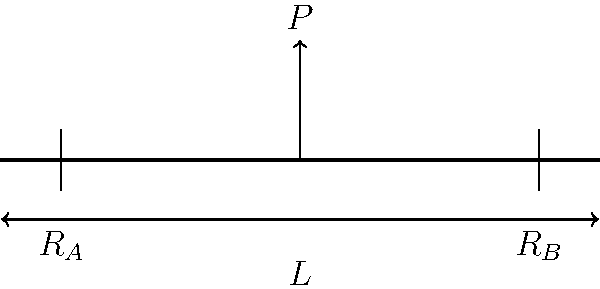As a vegan sales manager who appreciates the importance of structural integrity in food presentation, consider a simple beam bridge. The beam spans 10 meters and is subjected to a point load $P$ of 50 kN at its center. Calculate the maximum bending moment in the beam, expressed in kN·m. To solve this problem, we'll follow these steps:

1. Identify the given information:
   - Beam span (L) = 10 m
   - Point load (P) = 50 kN
   - Load is applied at the center of the beam

2. Calculate the reactions at the supports:
   Due to symmetry, each support carries half the total load.
   $R_A = R_B = P/2 = 50/2 = 25$ kN

3. Determine the maximum bending moment:
   For a simply supported beam with a point load at the center, the maximum bending moment occurs at the center and is given by the formula:

   $M_{max} = \frac{PL}{4}$

   Where:
   $M_{max}$ is the maximum bending moment
   $P$ is the point load
   $L$ is the span of the beam

4. Substitute the values:
   $M_{max} = \frac{50 \text{ kN} \times 10 \text{ m}}{4}$

5. Calculate the result:
   $M_{max} = 125 \text{ kN·m}$

This maximum bending moment represents the highest internal force that the beam must resist to maintain its structural integrity, similar to how a well-constructed vegan dish must maintain its form and texture under various conditions.
Answer: 125 kN·m 